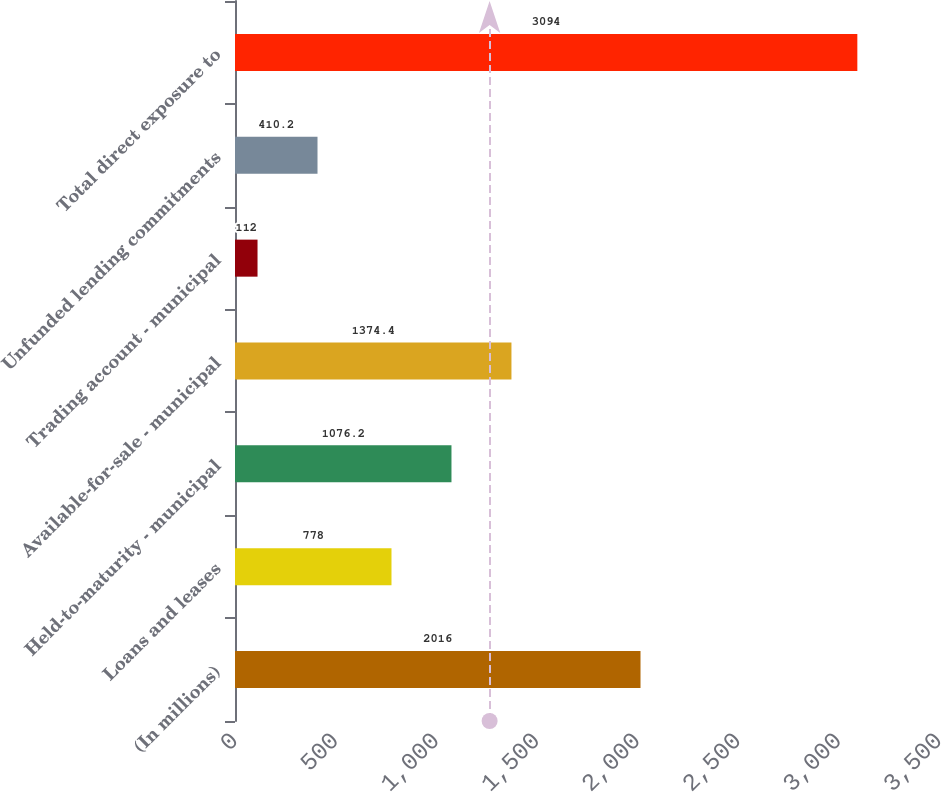Convert chart. <chart><loc_0><loc_0><loc_500><loc_500><bar_chart><fcel>(In millions)<fcel>Loans and leases<fcel>Held-to-maturity - municipal<fcel>Available-for-sale - municipal<fcel>Trading account - municipal<fcel>Unfunded lending commitments<fcel>Total direct exposure to<nl><fcel>2016<fcel>778<fcel>1076.2<fcel>1374.4<fcel>112<fcel>410.2<fcel>3094<nl></chart> 